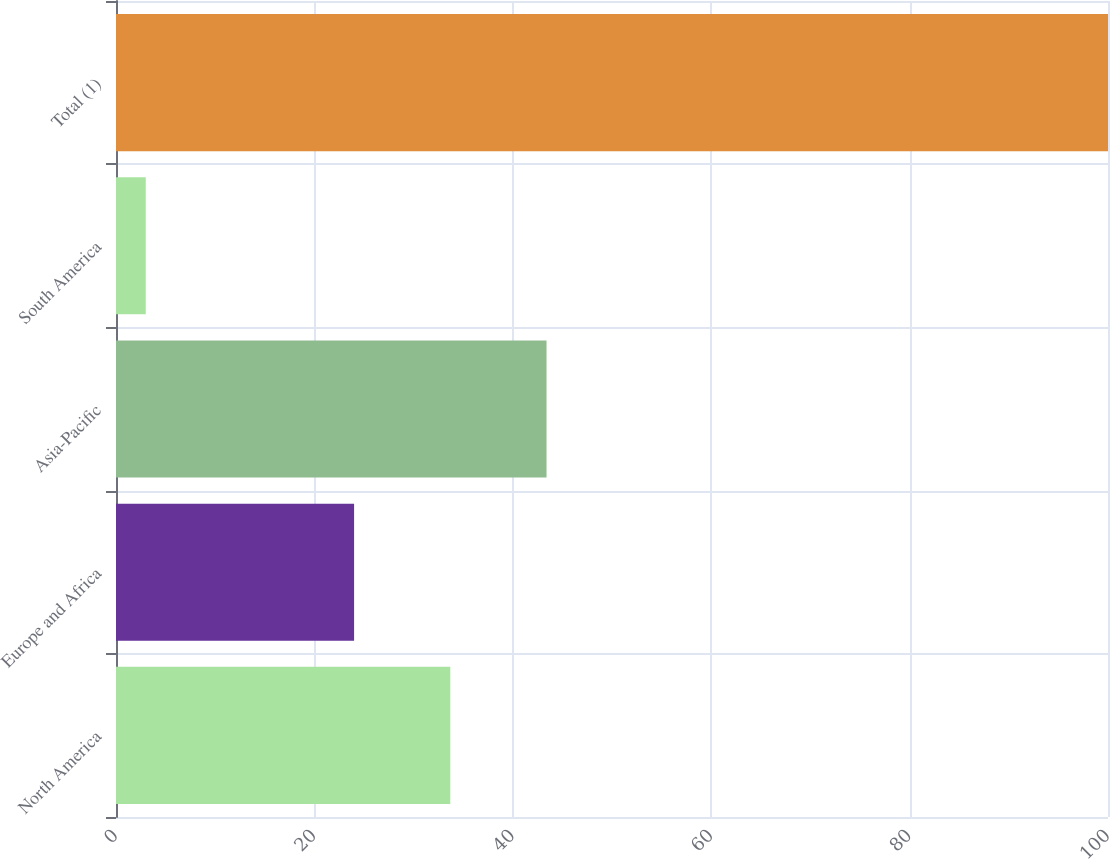<chart> <loc_0><loc_0><loc_500><loc_500><bar_chart><fcel>North America<fcel>Europe and Africa<fcel>Asia-Pacific<fcel>South America<fcel>Total (1)<nl><fcel>33.7<fcel>24<fcel>43.4<fcel>3<fcel>100<nl></chart> 